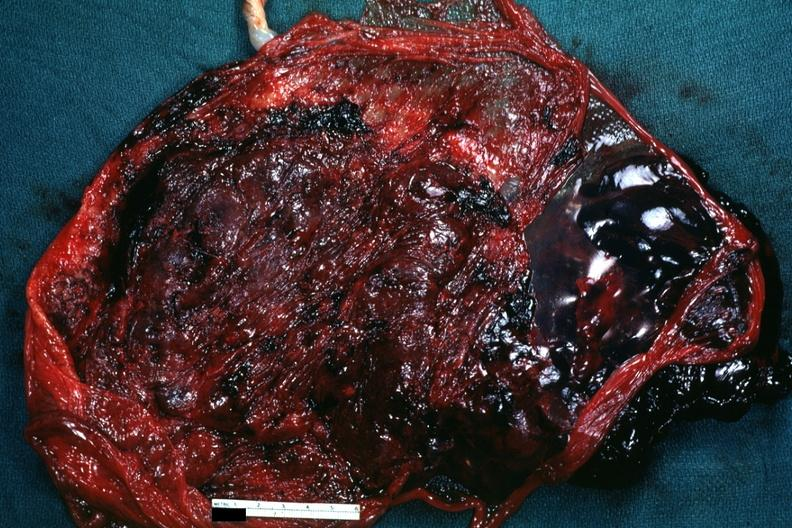s female reproductive present?
Answer the question using a single word or phrase. Yes 